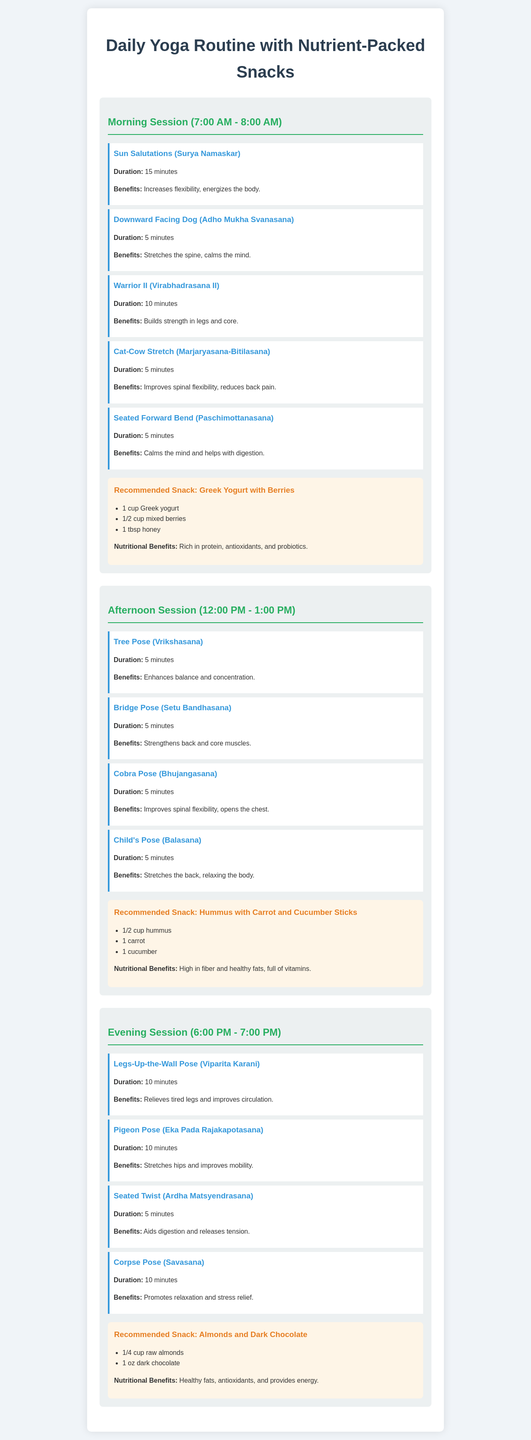What time is the morning yoga session? The morning yoga session is scheduled from 7:00 AM to 8:00 AM.
Answer: 7:00 AM - 8:00 AM How long do the Sun Salutations last? The duration of the Sun Salutations (Surya Namaskar) is 15 minutes.
Answer: 15 minutes What snack is recommended after the morning session? The recommended snack after the morning session is Greek Yogurt with Berries.
Answer: Greek Yogurt with Berries What are the nutritional benefits of the afternoon snack? The afternoon snack (Hummus with Carrot and Cucumber Sticks) is high in fiber and healthy fats, full of vitamins.
Answer: High in fiber and healthy fats, full of vitamins How many asanas are included in the evening session? The evening session includes four asanas: Legs-Up-the-Wall Pose, Pigeon Pose, Seated Twist, and Corpse Pose.
Answer: Four asanas What is the main benefit of the Warrior II pose? The main benefit of the Warrior II (Virabhadrasana II) pose is to build strength in legs and core.
Answer: Builds strength in legs and core Which snack contains dark chocolate? The snack that contains dark chocolate is Almonds and Dark Chocolate.
Answer: Almonds and Dark Chocolate During which session is the Child's Pose practiced? The Child's Pose (Balasana) is practiced during the afternoon session.
Answer: Afternoon session 